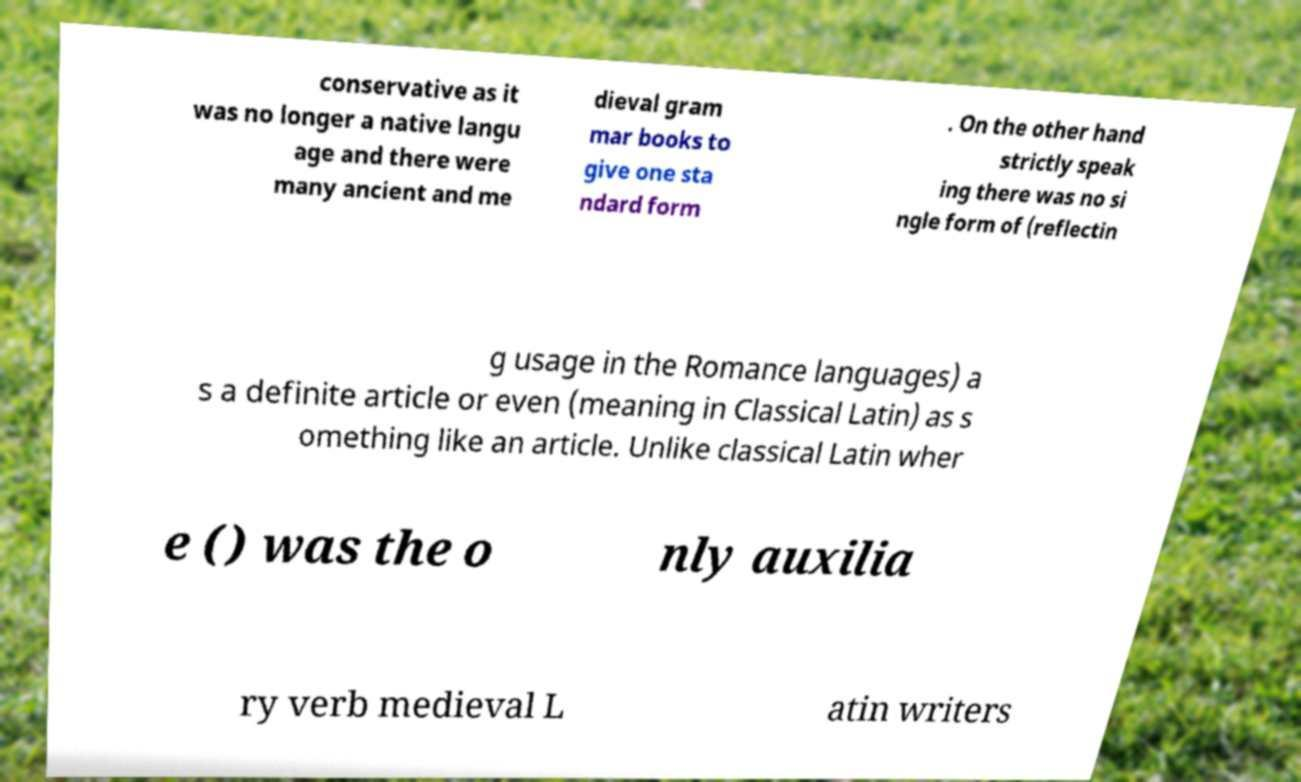What messages or text are displayed in this image? I need them in a readable, typed format. conservative as it was no longer a native langu age and there were many ancient and me dieval gram mar books to give one sta ndard form . On the other hand strictly speak ing there was no si ngle form of (reflectin g usage in the Romance languages) a s a definite article or even (meaning in Classical Latin) as s omething like an article. Unlike classical Latin wher e () was the o nly auxilia ry verb medieval L atin writers 